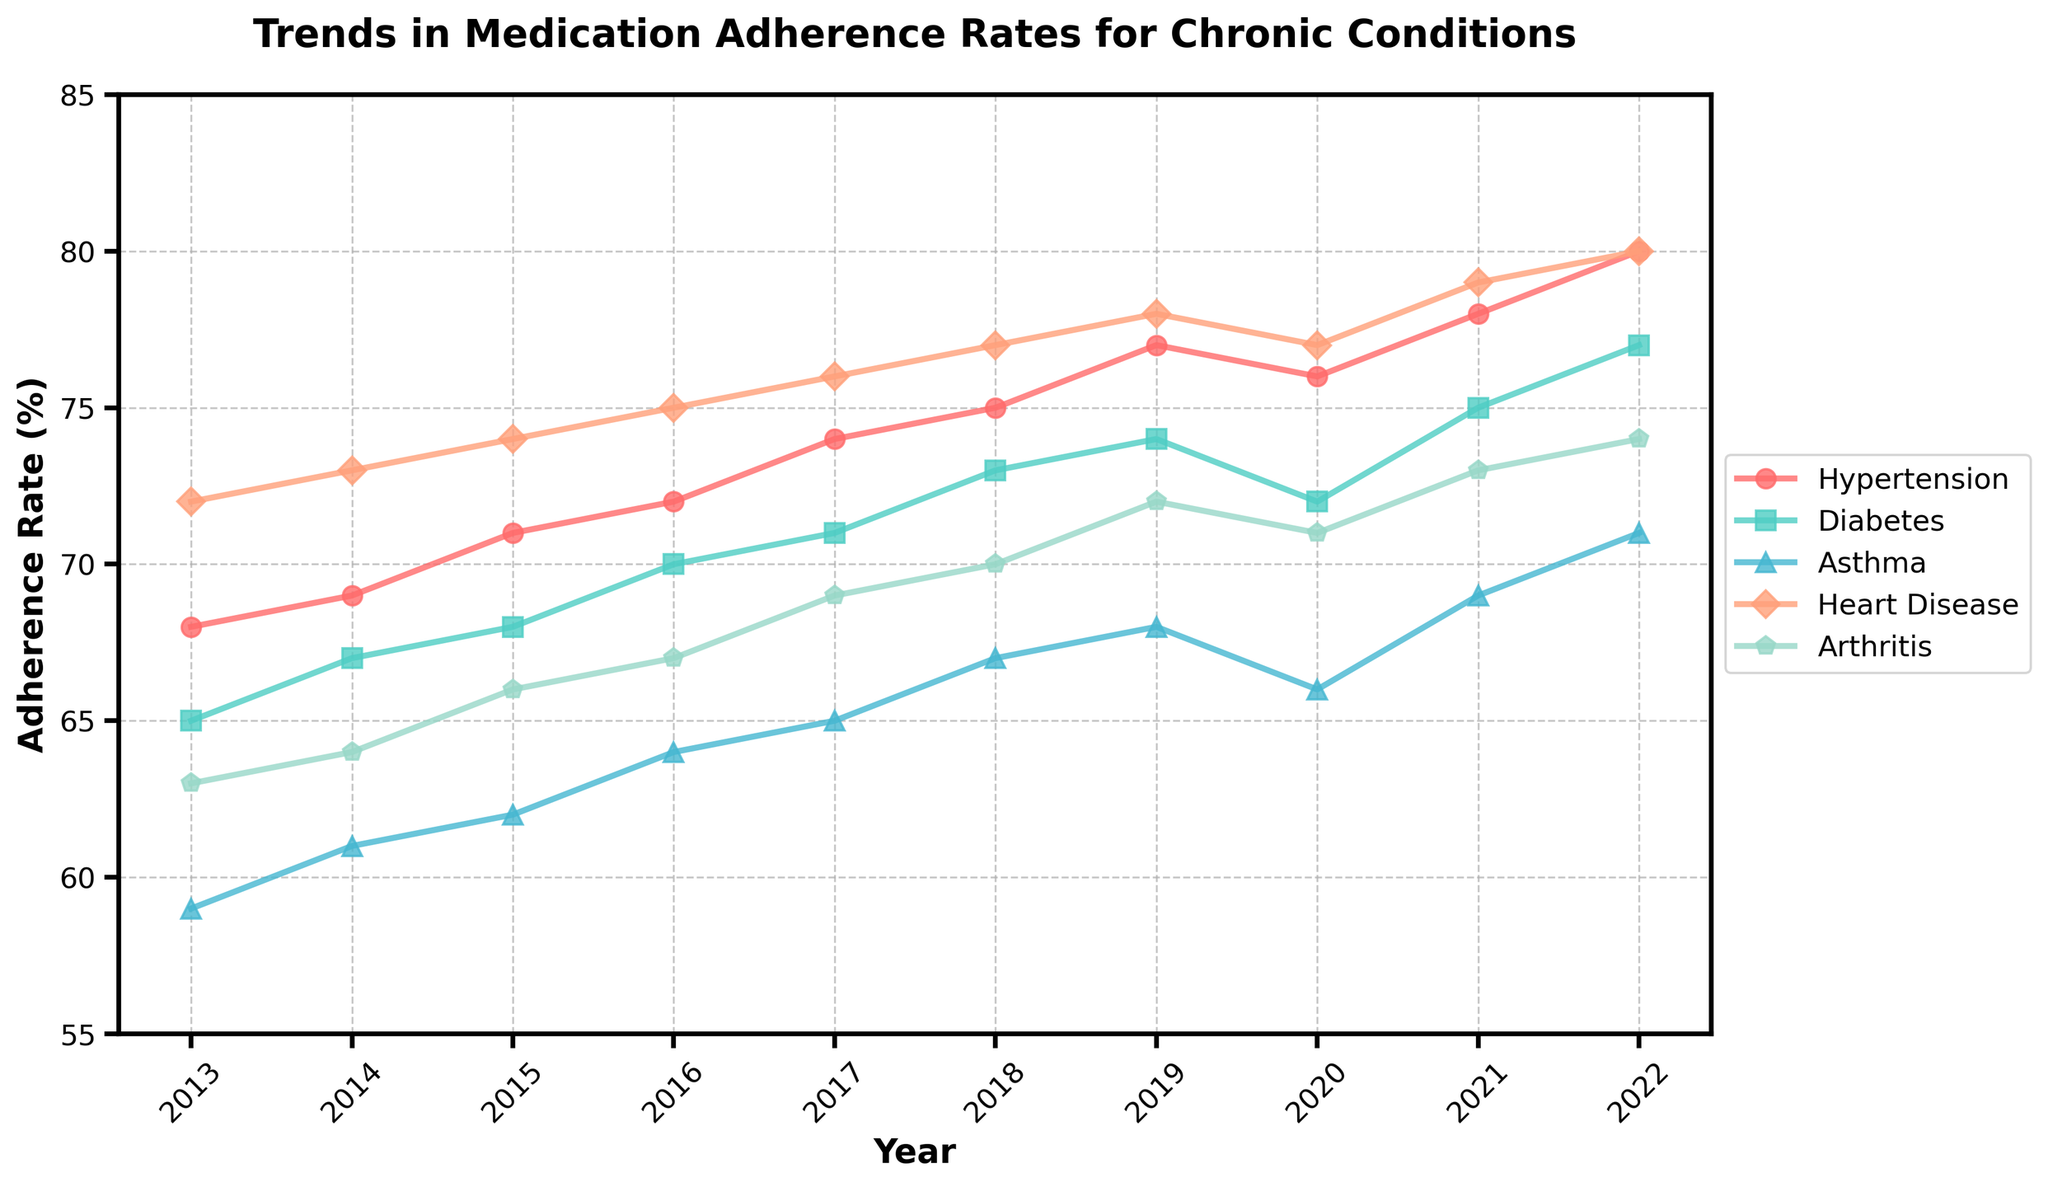What is the trend in medication adherence rates for Diabetes from 2013 to 2022? To analyze the trend, look at the positions of the Diabetes line plot from 2013 to 2022. The adherence rates gradually increase from 65% in 2013 to 77% in 2022.
Answer: Increasing Which chronic condition has the highest adherence rate in 2022? Examine the endpoints of all the lines on the plot for the year 2022. The Heart Disease line reaches the highest point at 80%.
Answer: Heart Disease By how many percentage points did the medication adherence rate for Hypertension change from 2013 to 2022? To find the change, subtract the adherence rate for Hypertension in 2013 from the rate in 2022: 80% (2022) - 68% (2013) = 12 percentage points.
Answer: 12 Which chronic condition had the lowest adherence rate in 2013? Look at the starting points of each line in the plot for the year 2013. The Asthma line is the lowest at 59%.
Answer: Asthma In which year did the medication adherence rate for Arthritis exceed 70%? Trace the Arthritis line on the plot and see when it crosses the 70% level. It crossed 70% in 2018.
Answer: 2018 Which condition showed a decrease in adherence rate between 2019 and 2020? Compare the adherence rates between 2019 and 2020 for each condition by observing the downward shift of lines. Only Hypertension showed a decrease from 77% to 76%.
Answer: Hypertension How many chronic conditions had an adherence rate of 75% or higher in 2022? Find all the lines that cross or surpass the 75% level in 2022. Hypertension, Diabetes, Heart Disease, and Arthritis all meet this criterion.
Answer: 4 What's the average adherence rate for Heart Disease over the decade? Add the adherence rates from 2013 to 2022 and divide by the number of years to get the average. (72 + 73 + 74 + 75 + 76 + 77 + 78 + 77 + 79 + 80)/10 = 76.1
Answer: 76.1 Which chronic condition has the least variation in adherence rates over the decade? Observe the spread of lines on the plot and identify the one with the flattest trend. Hypertension has the smallest range, varying from 68% to 80%.
Answer: Hypertension 